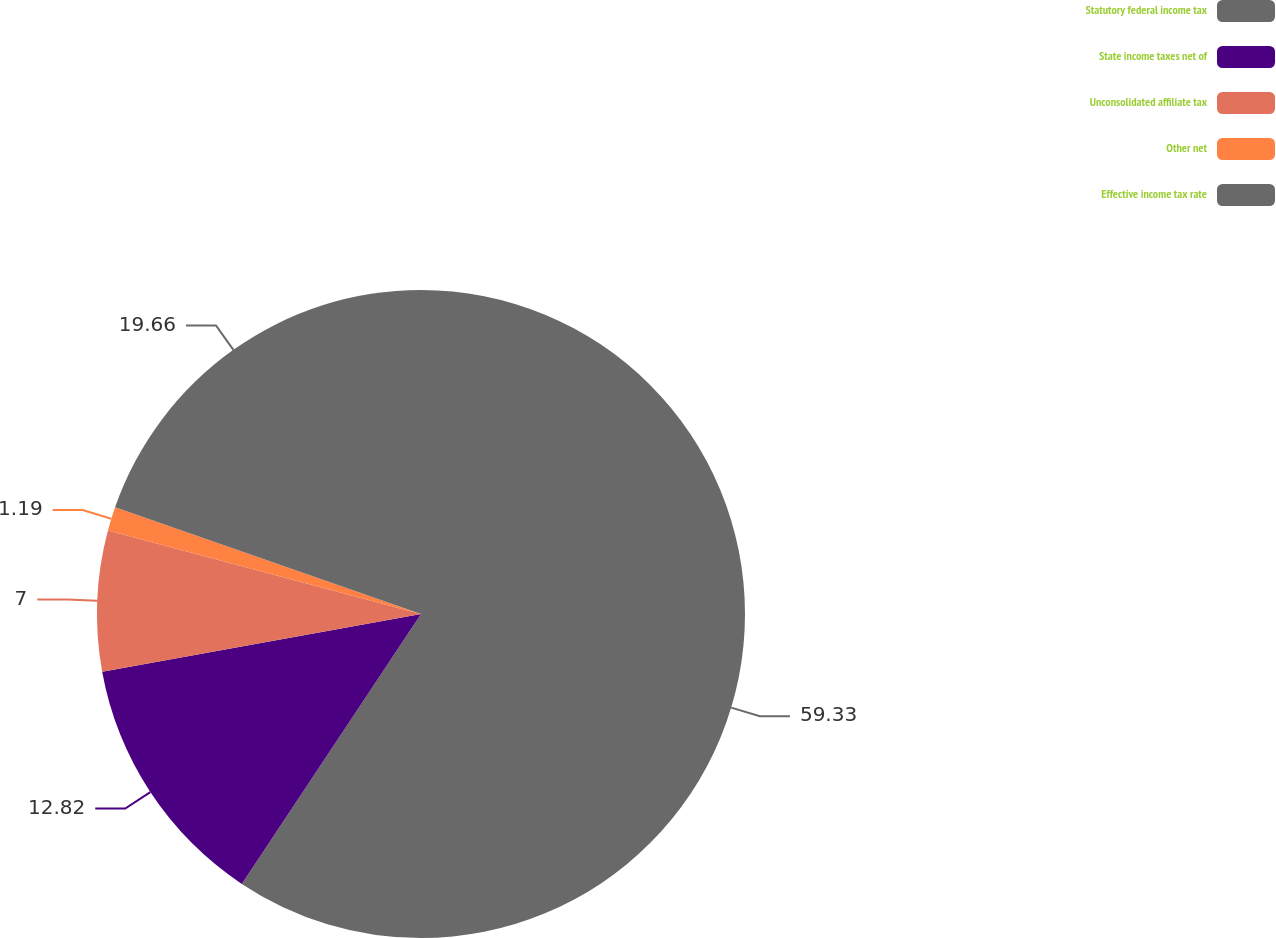<chart> <loc_0><loc_0><loc_500><loc_500><pie_chart><fcel>Statutory federal income tax<fcel>State income taxes net of<fcel>Unconsolidated affiliate tax<fcel>Other net<fcel>Effective income tax rate<nl><fcel>59.33%<fcel>12.82%<fcel>7.0%<fcel>1.19%<fcel>19.66%<nl></chart> 